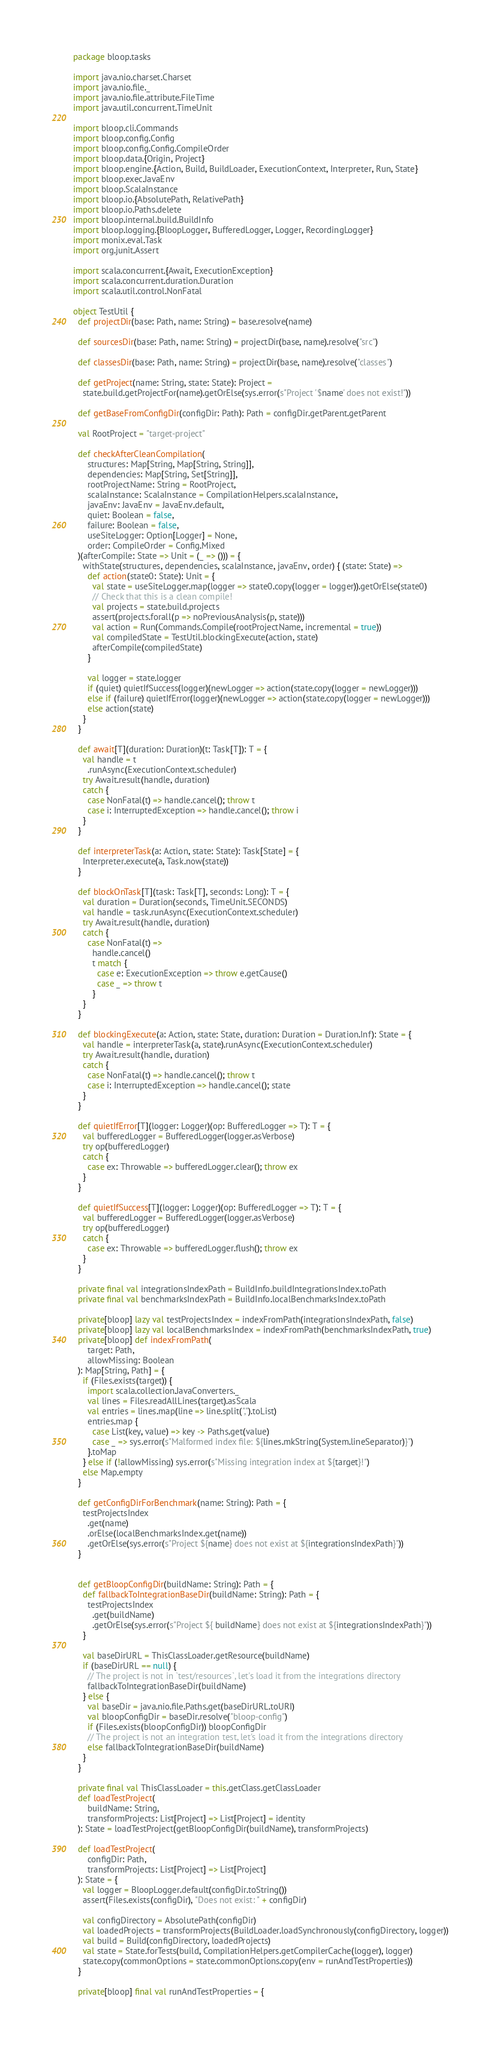<code> <loc_0><loc_0><loc_500><loc_500><_Scala_>package bloop.tasks

import java.nio.charset.Charset
import java.nio.file._
import java.nio.file.attribute.FileTime
import java.util.concurrent.TimeUnit

import bloop.cli.Commands
import bloop.config.Config
import bloop.config.Config.CompileOrder
import bloop.data.{Origin, Project}
import bloop.engine.{Action, Build, BuildLoader, ExecutionContext, Interpreter, Run, State}
import bloop.exec.JavaEnv
import bloop.ScalaInstance
import bloop.io.{AbsolutePath, RelativePath}
import bloop.io.Paths.delete
import bloop.internal.build.BuildInfo
import bloop.logging.{BloopLogger, BufferedLogger, Logger, RecordingLogger}
import monix.eval.Task
import org.junit.Assert

import scala.concurrent.{Await, ExecutionException}
import scala.concurrent.duration.Duration
import scala.util.control.NonFatal

object TestUtil {
  def projectDir(base: Path, name: String) = base.resolve(name)

  def sourcesDir(base: Path, name: String) = projectDir(base, name).resolve("src")

  def classesDir(base: Path, name: String) = projectDir(base, name).resolve("classes")

  def getProject(name: String, state: State): Project =
    state.build.getProjectFor(name).getOrElse(sys.error(s"Project '$name' does not exist!"))

  def getBaseFromConfigDir(configDir: Path): Path = configDir.getParent.getParent

  val RootProject = "target-project"

  def checkAfterCleanCompilation(
      structures: Map[String, Map[String, String]],
      dependencies: Map[String, Set[String]],
      rootProjectName: String = RootProject,
      scalaInstance: ScalaInstance = CompilationHelpers.scalaInstance,
      javaEnv: JavaEnv = JavaEnv.default,
      quiet: Boolean = false,
      failure: Boolean = false,
      useSiteLogger: Option[Logger] = None,
      order: CompileOrder = Config.Mixed
  )(afterCompile: State => Unit = (_ => ())) = {
    withState(structures, dependencies, scalaInstance, javaEnv, order) { (state: State) =>
      def action(state0: State): Unit = {
        val state = useSiteLogger.map(logger => state0.copy(logger = logger)).getOrElse(state0)
        // Check that this is a clean compile!
        val projects = state.build.projects
        assert(projects.forall(p => noPreviousAnalysis(p, state)))
        val action = Run(Commands.Compile(rootProjectName, incremental = true))
        val compiledState = TestUtil.blockingExecute(action, state)
        afterCompile(compiledState)
      }

      val logger = state.logger
      if (quiet) quietIfSuccess(logger)(newLogger => action(state.copy(logger = newLogger)))
      else if (failure) quietIfError(logger)(newLogger => action(state.copy(logger = newLogger)))
      else action(state)
    }
  }

  def await[T](duration: Duration)(t: Task[T]): T = {
    val handle = t
      .runAsync(ExecutionContext.scheduler)
    try Await.result(handle, duration)
    catch {
      case NonFatal(t) => handle.cancel(); throw t
      case i: InterruptedException => handle.cancel(); throw i
    }
  }

  def interpreterTask(a: Action, state: State): Task[State] = {
    Interpreter.execute(a, Task.now(state))
  }

  def blockOnTask[T](task: Task[T], seconds: Long): T = {
    val duration = Duration(seconds, TimeUnit.SECONDS)
    val handle = task.runAsync(ExecutionContext.scheduler)
    try Await.result(handle, duration)
    catch {
      case NonFatal(t) =>
        handle.cancel()
        t match {
          case e: ExecutionException => throw e.getCause()
          case _ => throw t
        }
    }
  }

  def blockingExecute(a: Action, state: State, duration: Duration = Duration.Inf): State = {
    val handle = interpreterTask(a, state).runAsync(ExecutionContext.scheduler)
    try Await.result(handle, duration)
    catch {
      case NonFatal(t) => handle.cancel(); throw t
      case i: InterruptedException => handle.cancel(); state
    }
  }

  def quietIfError[T](logger: Logger)(op: BufferedLogger => T): T = {
    val bufferedLogger = BufferedLogger(logger.asVerbose)
    try op(bufferedLogger)
    catch {
      case ex: Throwable => bufferedLogger.clear(); throw ex
    }
  }

  def quietIfSuccess[T](logger: Logger)(op: BufferedLogger => T): T = {
    val bufferedLogger = BufferedLogger(logger.asVerbose)
    try op(bufferedLogger)
    catch {
      case ex: Throwable => bufferedLogger.flush(); throw ex
    }
  }

  private final val integrationsIndexPath = BuildInfo.buildIntegrationsIndex.toPath
  private final val benchmarksIndexPath = BuildInfo.localBenchmarksIndex.toPath

  private[bloop] lazy val testProjectsIndex = indexFromPath(integrationsIndexPath, false)
  private[bloop] lazy val localBenchmarksIndex = indexFromPath(benchmarksIndexPath, true)
  private[bloop] def indexFromPath(
      target: Path,
      allowMissing: Boolean
  ): Map[String, Path] = {
    if (Files.exists(target)) {
      import scala.collection.JavaConverters._
      val lines = Files.readAllLines(target).asScala
      val entries = lines.map(line => line.split(",").toList)
      entries.map {
        case List(key, value) => key -> Paths.get(value)
        case _ => sys.error(s"Malformed index file: ${lines.mkString(System.lineSeparator)}")
      }.toMap
    } else if (!allowMissing) sys.error(s"Missing integration index at ${target}!")
    else Map.empty
  }

  def getConfigDirForBenchmark(name: String): Path = {
    testProjectsIndex
      .get(name)
      .orElse(localBenchmarksIndex.get(name))
      .getOrElse(sys.error(s"Project ${name} does not exist at ${integrationsIndexPath}"))
  }


  def getBloopConfigDir(buildName: String): Path = {
    def fallbackToIntegrationBaseDir(buildName: String): Path = {
      testProjectsIndex
        .get(buildName)
        .getOrElse(sys.error(s"Project ${ buildName} does not exist at ${integrationsIndexPath}"))
    }

    val baseDirURL = ThisClassLoader.getResource(buildName)
    if (baseDirURL == null) {
      // The project is not in `test/resources`, let's load it from the integrations directory
      fallbackToIntegrationBaseDir(buildName)
    } else {
      val baseDir = java.nio.file.Paths.get(baseDirURL.toURI)
      val bloopConfigDir = baseDir.resolve("bloop-config")
      if (Files.exists(bloopConfigDir)) bloopConfigDir
      // The project is not an integration test, let's load it from the integrations directory
      else fallbackToIntegrationBaseDir(buildName)
    }
  }

  private final val ThisClassLoader = this.getClass.getClassLoader
  def loadTestProject(
      buildName: String,
      transformProjects: List[Project] => List[Project] = identity
  ): State = loadTestProject(getBloopConfigDir(buildName), transformProjects)

  def loadTestProject(
      configDir: Path,
      transformProjects: List[Project] => List[Project]
  ): State = {
    val logger = BloopLogger.default(configDir.toString())
    assert(Files.exists(configDir), "Does not exist: " + configDir)

    val configDirectory = AbsolutePath(configDir)
    val loadedProjects = transformProjects(BuildLoader.loadSynchronously(configDirectory, logger))
    val build = Build(configDirectory, loadedProjects)
    val state = State.forTests(build, CompilationHelpers.getCompilerCache(logger), logger)
    state.copy(commonOptions = state.commonOptions.copy(env = runAndTestProperties))
  }

  private[bloop] final val runAndTestProperties = {</code> 